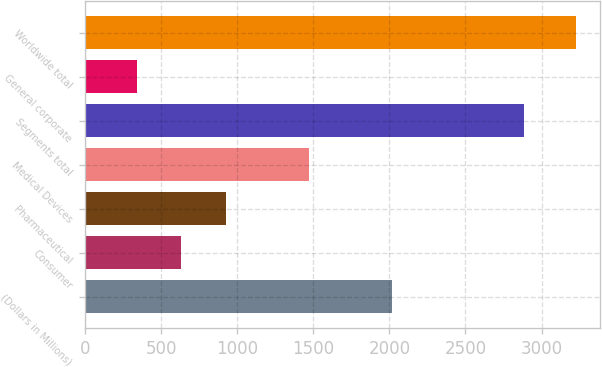<chart> <loc_0><loc_0><loc_500><loc_500><bar_chart><fcel>(Dollars in Millions)<fcel>Consumer<fcel>Pharmaceutical<fcel>Medical Devices<fcel>Segments total<fcel>General corporate<fcel>Worldwide total<nl><fcel>2016<fcel>629.5<fcel>927<fcel>1472<fcel>2885<fcel>341<fcel>3226<nl></chart> 